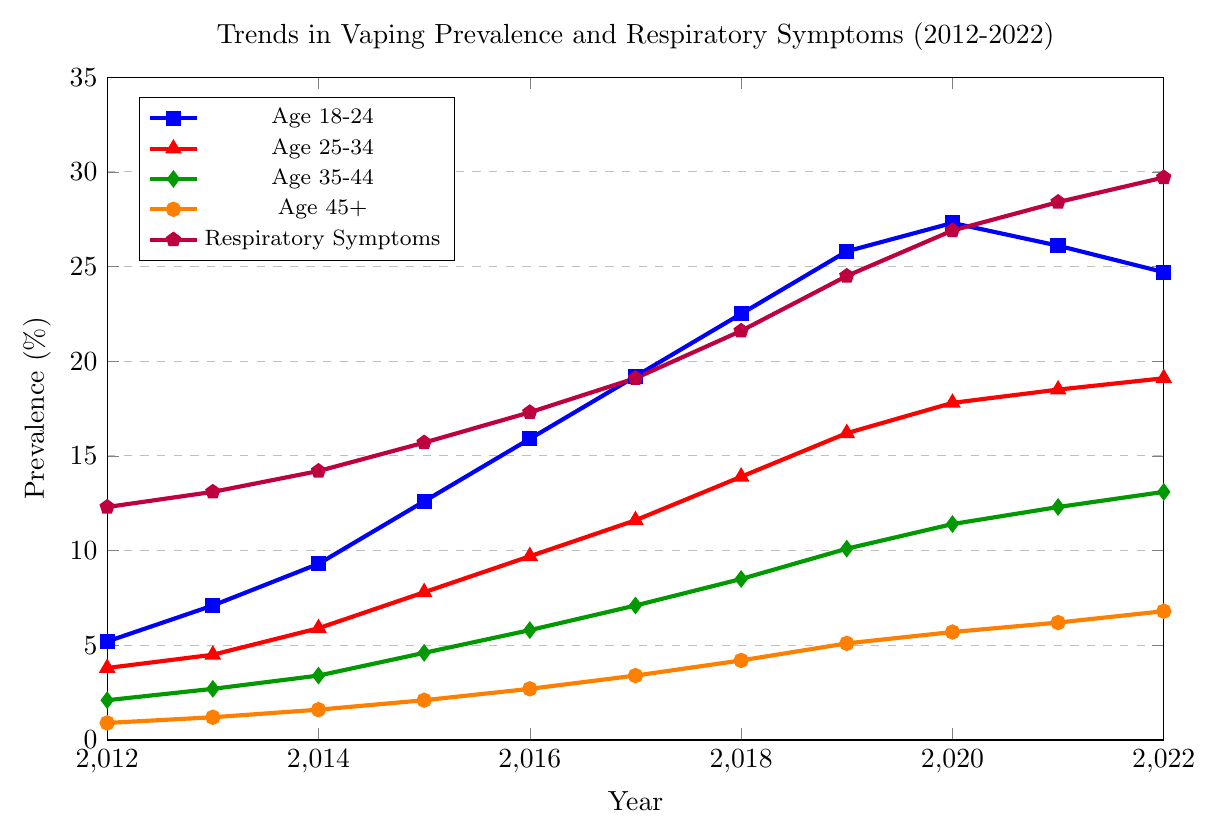What was the trend in vaping prevalence for the age group 18-24 from 2012 to 2022? The prevalence of vaping among the age group 18-24 shows a general increase from 5.2% in 2012 to a peak of 27.3% in 2020 before slightly declining to 24.7% in 2022.
Answer: General increase, peak at 27.3% in 2020, slight decline to 24.7% in 2022 Which age group had the largest increase in vaping prevalence from 2012 to 2022? The age group 18-24 had the largest increase in vaping prevalence, starting at 5.2% in 2012 and reaching 24.7% in 2022, a net increase of 19.5 percentage points.
Answer: Age group 18-24 How did reported respiratory symptoms change over the period from 2012 to 2022? Reported respiratory symptoms increased from 12.3% in 2012 to 29.7% in 2022, showing a continuous upward trend over the decade.
Answer: Increased from 12.3% to 29.7% In what year did the age group 25-34 see the highest prevalence of vaping? The highest prevalence of vaping for the age group 25-34 was in 2022, with a prevalence of 19.1%.
Answer: 2022 Compare the vaping prevalence between the age groups 35-44 and 45+ in 2020. Which group had a higher prevalence and by how much? In 2020, the age group 35-44 had a vaping prevalence of 11.4%, while the age group 45+ had a prevalence of 5.7%. The age group 35-44 had a higher prevalence by 5.7 percentage points.
Answer: Age group 35-44, 5.7 percentage points higher What is the correlation between the trends in vaping prevalence (for any age group) and reported respiratory symptoms from 2012 to 2022? Both vaping prevalence across all age groups and reported respiratory symptoms show an increasing trend over the decade, suggesting a potential positive correlation.
Answer: Positive correlation What was the percentage difference in vaping prevalence between the age groups 18-24 and 25-34 in the year 2018? In 2018, the vaping prevalence for the age group 18-24 was 22.5%, and for the age group 25-34, it was 13.9%. The difference is 22.5% - 13.9% = 8.6 percentage points.
Answer: 8.6 percentage points What is the overall trend of vaping prevalence for the age group 45+ and how does it compare to the trend in reported respiratory symptoms over the same period? The vaping prevalence for the age group 45+ shows a gradual increase from 0.9% in 2012 to 6.8% in 2022. Similarly, reported respiratory symptoms increased from 12.3% to 29.7% over the same period, indicating both trends show a consistent rise.
Answer: Both show a consistent rise Between which two consecutive years did the age group 35-44 see the largest increase in vaping prevalence? The largest increase for the age group 35-44 occurred between 2018 and 2019, where the prevalence increased from 8.5% to 10.1%, a difference of 1.6 percentage points.
Answer: Between 2018 and 2019 What was the approximate percentage of reported respiratory symptoms in 2017, and how does it compare visually to the vaping prevalence in the same year for the age group 18-24? In 2017, the reported respiratory symptoms were approximately 19.1%. Visually, this is almost the same as the vaping prevalence for the age group 18-24, which is also 19.2%.
Answer: Approximately the same (around 19.1%-19.2%) 